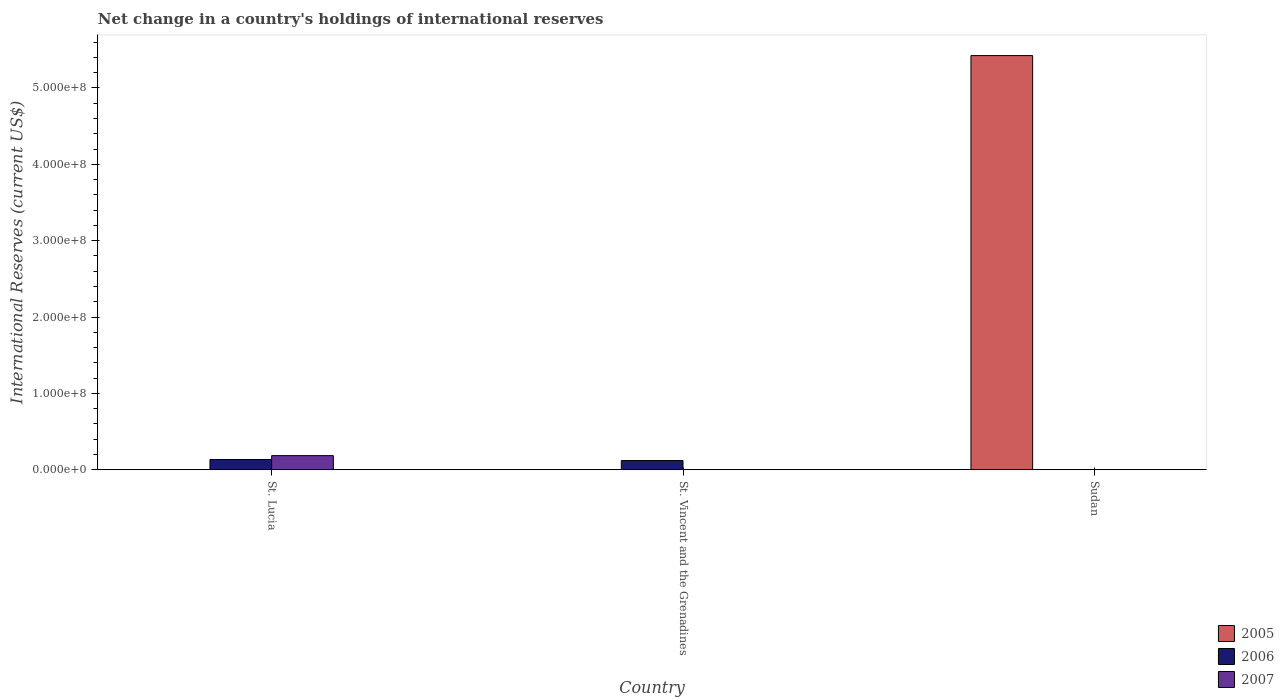Are the number of bars per tick equal to the number of legend labels?
Offer a very short reply. No. Are the number of bars on each tick of the X-axis equal?
Make the answer very short. No. How many bars are there on the 1st tick from the left?
Your response must be concise. 2. How many bars are there on the 2nd tick from the right?
Offer a terse response. 1. What is the label of the 1st group of bars from the left?
Give a very brief answer. St. Lucia. Across all countries, what is the maximum international reserves in 2007?
Give a very brief answer. 1.86e+07. In which country was the international reserves in 2006 maximum?
Your response must be concise. St. Lucia. What is the total international reserves in 2005 in the graph?
Your response must be concise. 5.42e+08. What is the difference between the international reserves in 2006 in St. Lucia and that in St. Vincent and the Grenadines?
Your response must be concise. 1.37e+06. What is the average international reserves in 2007 per country?
Provide a succinct answer. 6.19e+06. What is the difference between the international reserves of/in 2007 and international reserves of/in 2006 in St. Lucia?
Make the answer very short. 5.10e+06. In how many countries, is the international reserves in 2006 greater than 180000000 US$?
Your answer should be very brief. 0. What is the difference between the highest and the lowest international reserves in 2005?
Your answer should be very brief. 5.42e+08. Is it the case that in every country, the sum of the international reserves in 2007 and international reserves in 2005 is greater than the international reserves in 2006?
Offer a very short reply. No. Are all the bars in the graph horizontal?
Your response must be concise. No. How many countries are there in the graph?
Your answer should be compact. 3. Are the values on the major ticks of Y-axis written in scientific E-notation?
Your response must be concise. Yes. Where does the legend appear in the graph?
Give a very brief answer. Bottom right. How many legend labels are there?
Provide a succinct answer. 3. How are the legend labels stacked?
Provide a short and direct response. Vertical. What is the title of the graph?
Provide a succinct answer. Net change in a country's holdings of international reserves. Does "1982" appear as one of the legend labels in the graph?
Your answer should be very brief. No. What is the label or title of the Y-axis?
Provide a short and direct response. International Reserves (current US$). What is the International Reserves (current US$) in 2006 in St. Lucia?
Offer a very short reply. 1.35e+07. What is the International Reserves (current US$) of 2007 in St. Lucia?
Offer a very short reply. 1.86e+07. What is the International Reserves (current US$) in 2006 in St. Vincent and the Grenadines?
Give a very brief answer. 1.21e+07. What is the International Reserves (current US$) in 2005 in Sudan?
Make the answer very short. 5.42e+08. What is the International Reserves (current US$) of 2006 in Sudan?
Make the answer very short. 0. What is the International Reserves (current US$) in 2007 in Sudan?
Your response must be concise. 0. Across all countries, what is the maximum International Reserves (current US$) in 2005?
Offer a very short reply. 5.42e+08. Across all countries, what is the maximum International Reserves (current US$) in 2006?
Make the answer very short. 1.35e+07. Across all countries, what is the maximum International Reserves (current US$) in 2007?
Your answer should be compact. 1.86e+07. Across all countries, what is the minimum International Reserves (current US$) in 2005?
Offer a very short reply. 0. What is the total International Reserves (current US$) of 2005 in the graph?
Provide a short and direct response. 5.42e+08. What is the total International Reserves (current US$) in 2006 in the graph?
Keep it short and to the point. 2.56e+07. What is the total International Reserves (current US$) in 2007 in the graph?
Your answer should be compact. 1.86e+07. What is the difference between the International Reserves (current US$) of 2006 in St. Lucia and that in St. Vincent and the Grenadines?
Provide a short and direct response. 1.37e+06. What is the average International Reserves (current US$) of 2005 per country?
Provide a short and direct response. 1.81e+08. What is the average International Reserves (current US$) in 2006 per country?
Ensure brevity in your answer.  8.53e+06. What is the average International Reserves (current US$) of 2007 per country?
Your response must be concise. 6.19e+06. What is the difference between the International Reserves (current US$) in 2006 and International Reserves (current US$) in 2007 in St. Lucia?
Keep it short and to the point. -5.10e+06. What is the ratio of the International Reserves (current US$) of 2006 in St. Lucia to that in St. Vincent and the Grenadines?
Ensure brevity in your answer.  1.11. What is the difference between the highest and the lowest International Reserves (current US$) of 2005?
Your answer should be very brief. 5.42e+08. What is the difference between the highest and the lowest International Reserves (current US$) in 2006?
Give a very brief answer. 1.35e+07. What is the difference between the highest and the lowest International Reserves (current US$) of 2007?
Provide a succinct answer. 1.86e+07. 